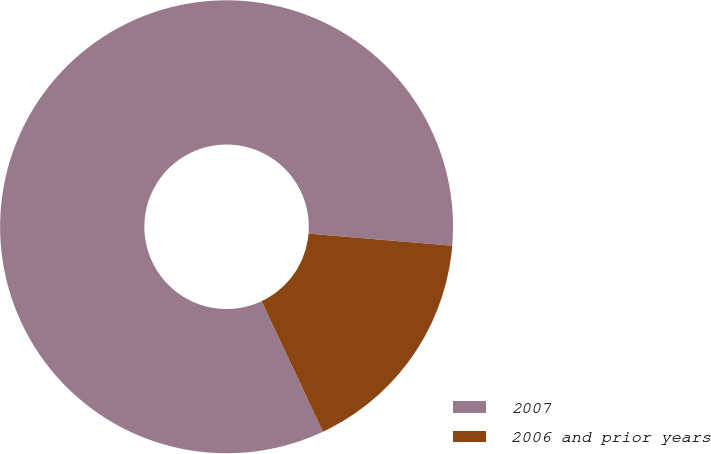Convert chart. <chart><loc_0><loc_0><loc_500><loc_500><pie_chart><fcel>2007<fcel>2006 and prior years<nl><fcel>83.33%<fcel>16.67%<nl></chart> 